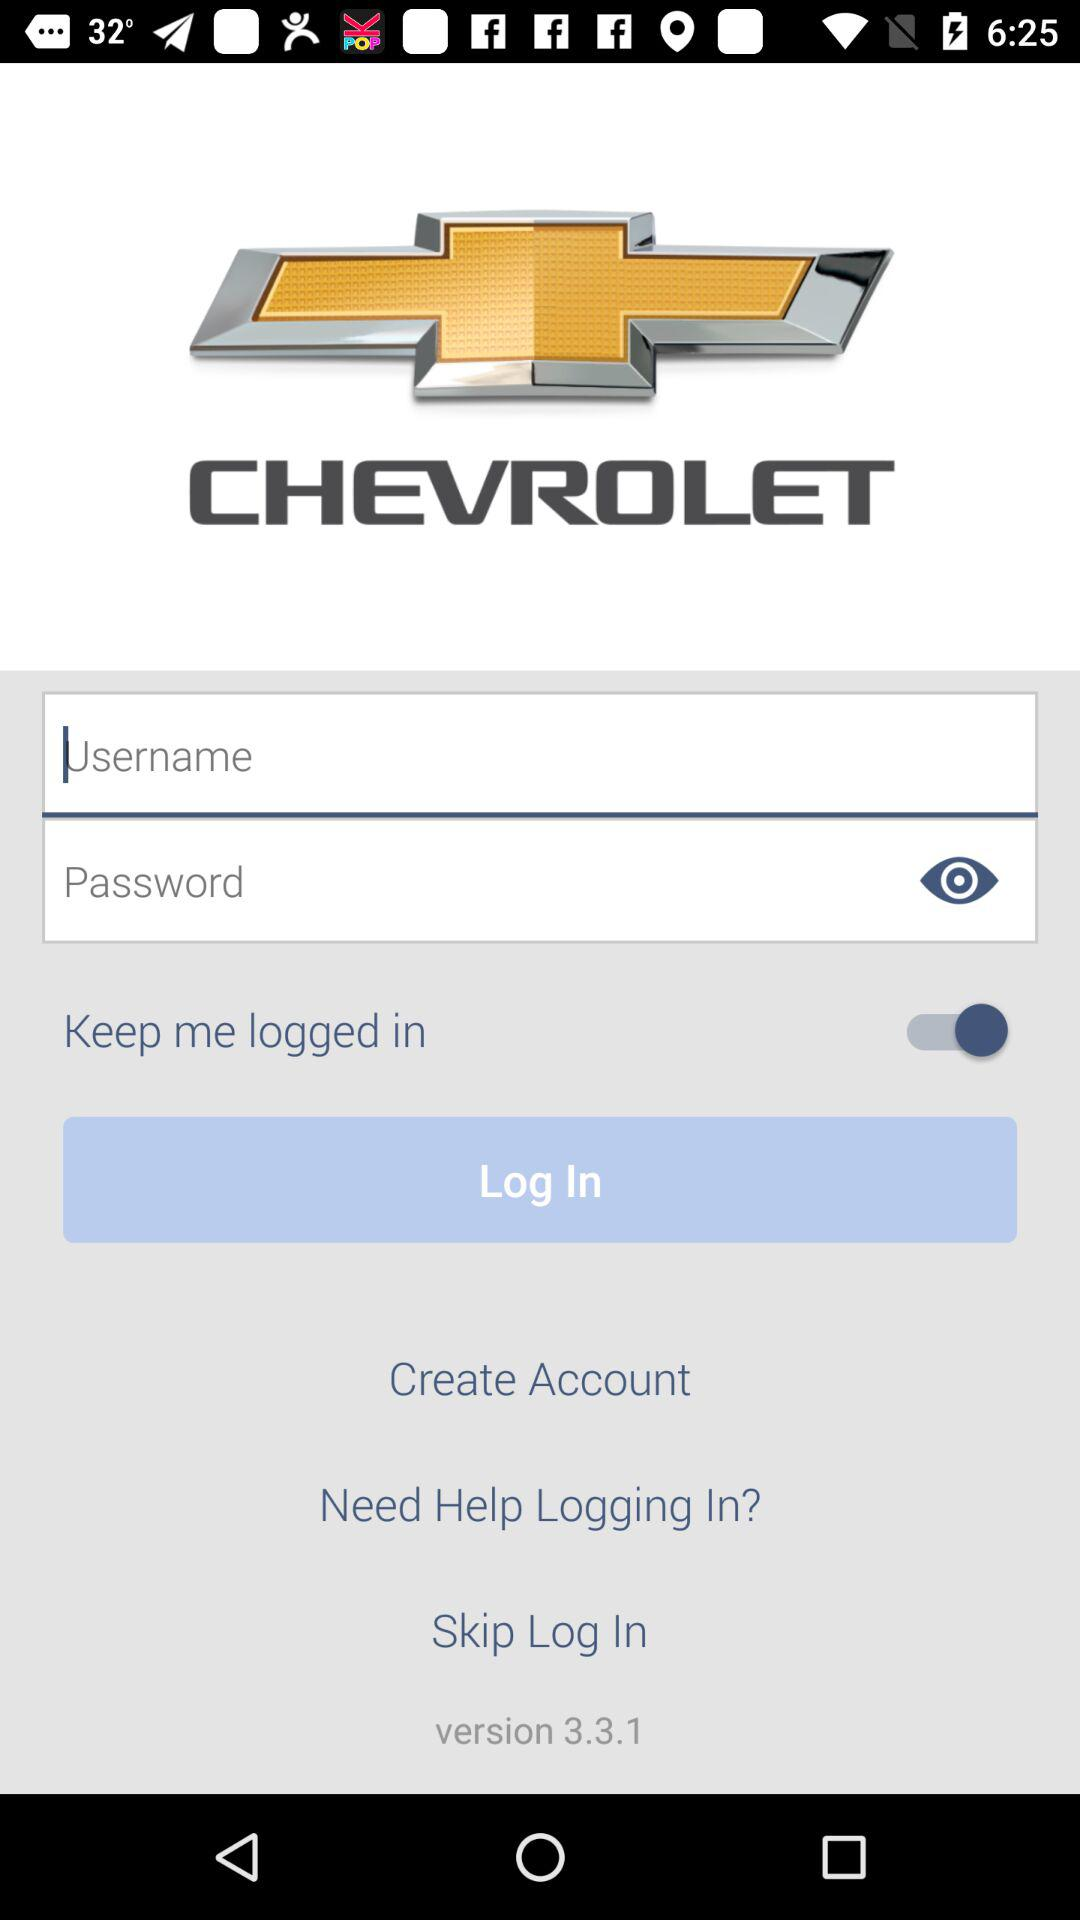What is the name of the application? The name of the application is "myChevrolet". 